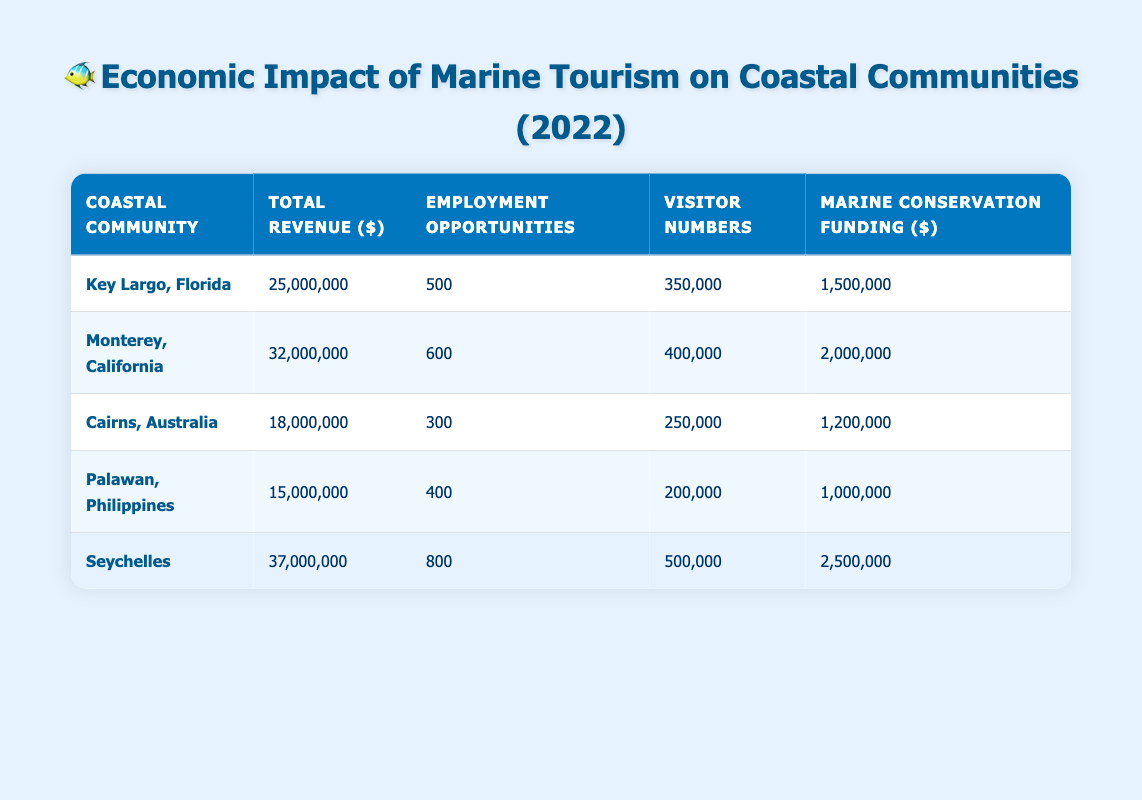What is the total revenue generated by Seychelles in 2022? The table lists the total revenue for Seychelles as 37,000,000.
Answer: 37,000,000 How many employment opportunities does Key Largo, Florida provide? According to the table, Key Largo, Florida has 500 employment opportunities listed.
Answer: 500 What is the sum of marine conservation funding for all communities? Adding the marine conservation funding from all communities: 1,500,000 + 2,000,000 + 1,200,000 + 1,000,000 + 2,500,000 = 8,200,000.
Answer: 8,200,000 Is the number of visitors to Cairns, Australia greater than that of Palawan, Philippines? The visitor numbers for Cairns, Australia is 250,000, while for Palawan, Philippines it is 200,000. Since 250,000 is greater than 200,000, the answer is yes.
Answer: Yes Which coastal community has the highest employment opportunities? Looking at the employment opportunities: Key Largo (500), Monterey (600), Cairns (300), Palawan (400), and Seychelles (800). The highest is Seychelles with 800 employment opportunities.
Answer: Seychelles What is the average total revenue of all the coastal communities? The total revenues are: 25,000,000 + 32,000,000 + 18,000,000 + 15,000,000 + 37,000,000 = 127,000,000. There are 5 communities, so the average is 127,000,000 / 5 = 25,400,000.
Answer: 25,400,000 Is it true that Monterey, California has more visitors than Seychelles? The visitor numbers are 400,000 for Monterey, California and 500,000 for Seychelles. Since 400,000 is less than 500,000, the answer is no.
Answer: No What is the difference in total revenue between Seychelles and Cairns, Australia? Seychelles has total revenue of 37,000,000 and Cairns has 18,000,000. The difference is 37,000,000 - 18,000,000 = 19,000,000.
Answer: 19,000,000 Which community had the least amount of marine conservation funding in 2022? Reviewing the marine conservation funding: 1,500,000 (Key Largo), 2,000,000 (Monterey), 1,200,000 (Cairns), 1,000,000 (Palawan), and 2,500,000 (Seychelles). The least is Palawan with 1,000,000.
Answer: Palawan 